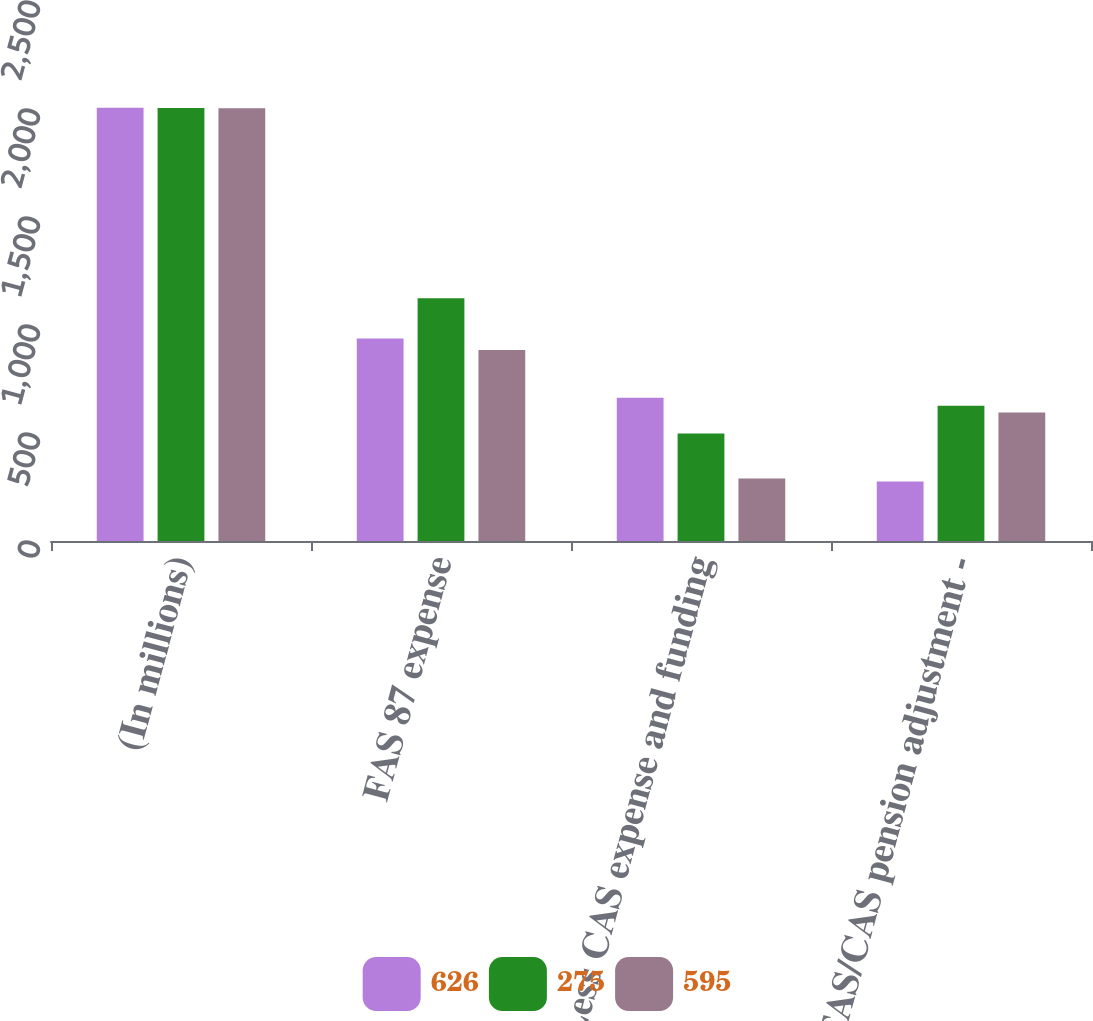Convert chart. <chart><loc_0><loc_0><loc_500><loc_500><stacked_bar_chart><ecel><fcel>(In millions)<fcel>FAS 87 expense<fcel>Less CAS expense and funding<fcel>FAS/CAS pension adjustment -<nl><fcel>626<fcel>2006<fcel>938<fcel>663<fcel>275<nl><fcel>275<fcel>2005<fcel>1124<fcel>498<fcel>626<nl><fcel>595<fcel>2004<fcel>884<fcel>289<fcel>595<nl></chart> 